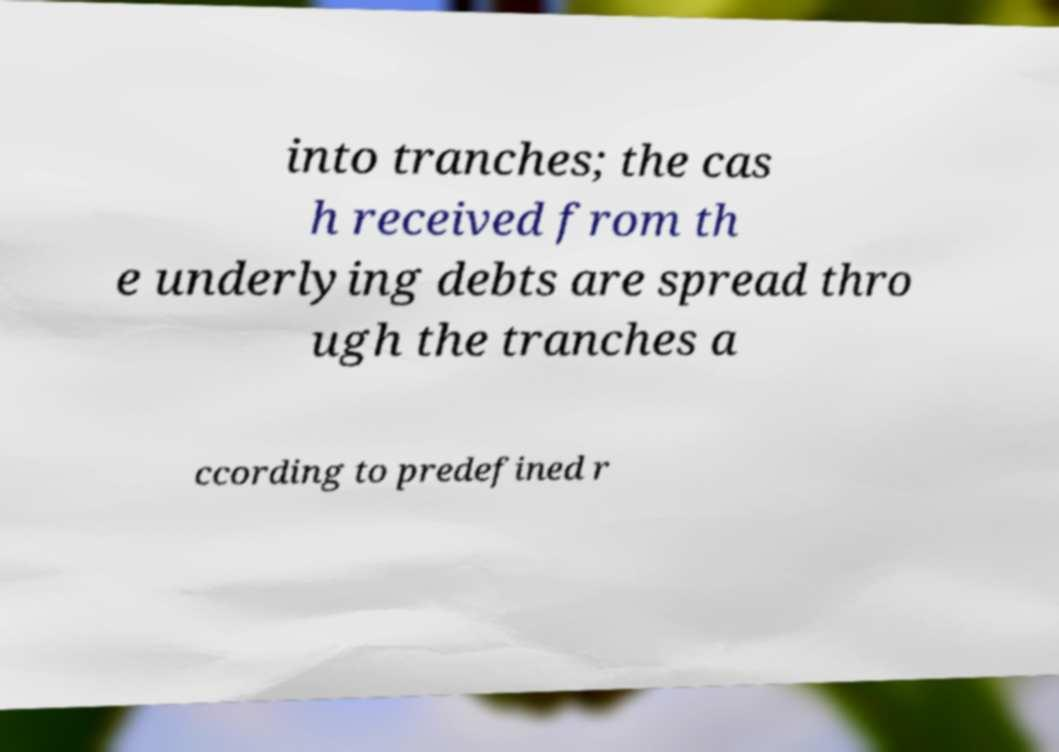Please read and relay the text visible in this image. What does it say? into tranches; the cas h received from th e underlying debts are spread thro ugh the tranches a ccording to predefined r 